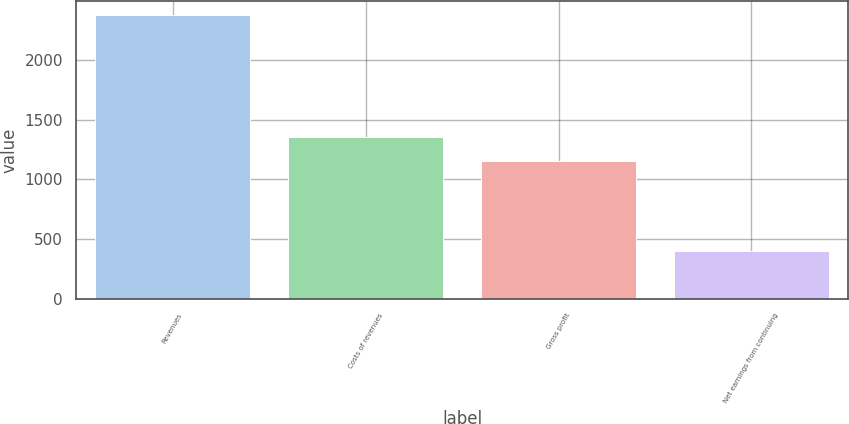Convert chart to OTSL. <chart><loc_0><loc_0><loc_500><loc_500><bar_chart><fcel>Revenues<fcel>Costs of revenues<fcel>Gross profit<fcel>Net earnings from continuing<nl><fcel>2374.7<fcel>1353.32<fcel>1156.1<fcel>402.5<nl></chart> 